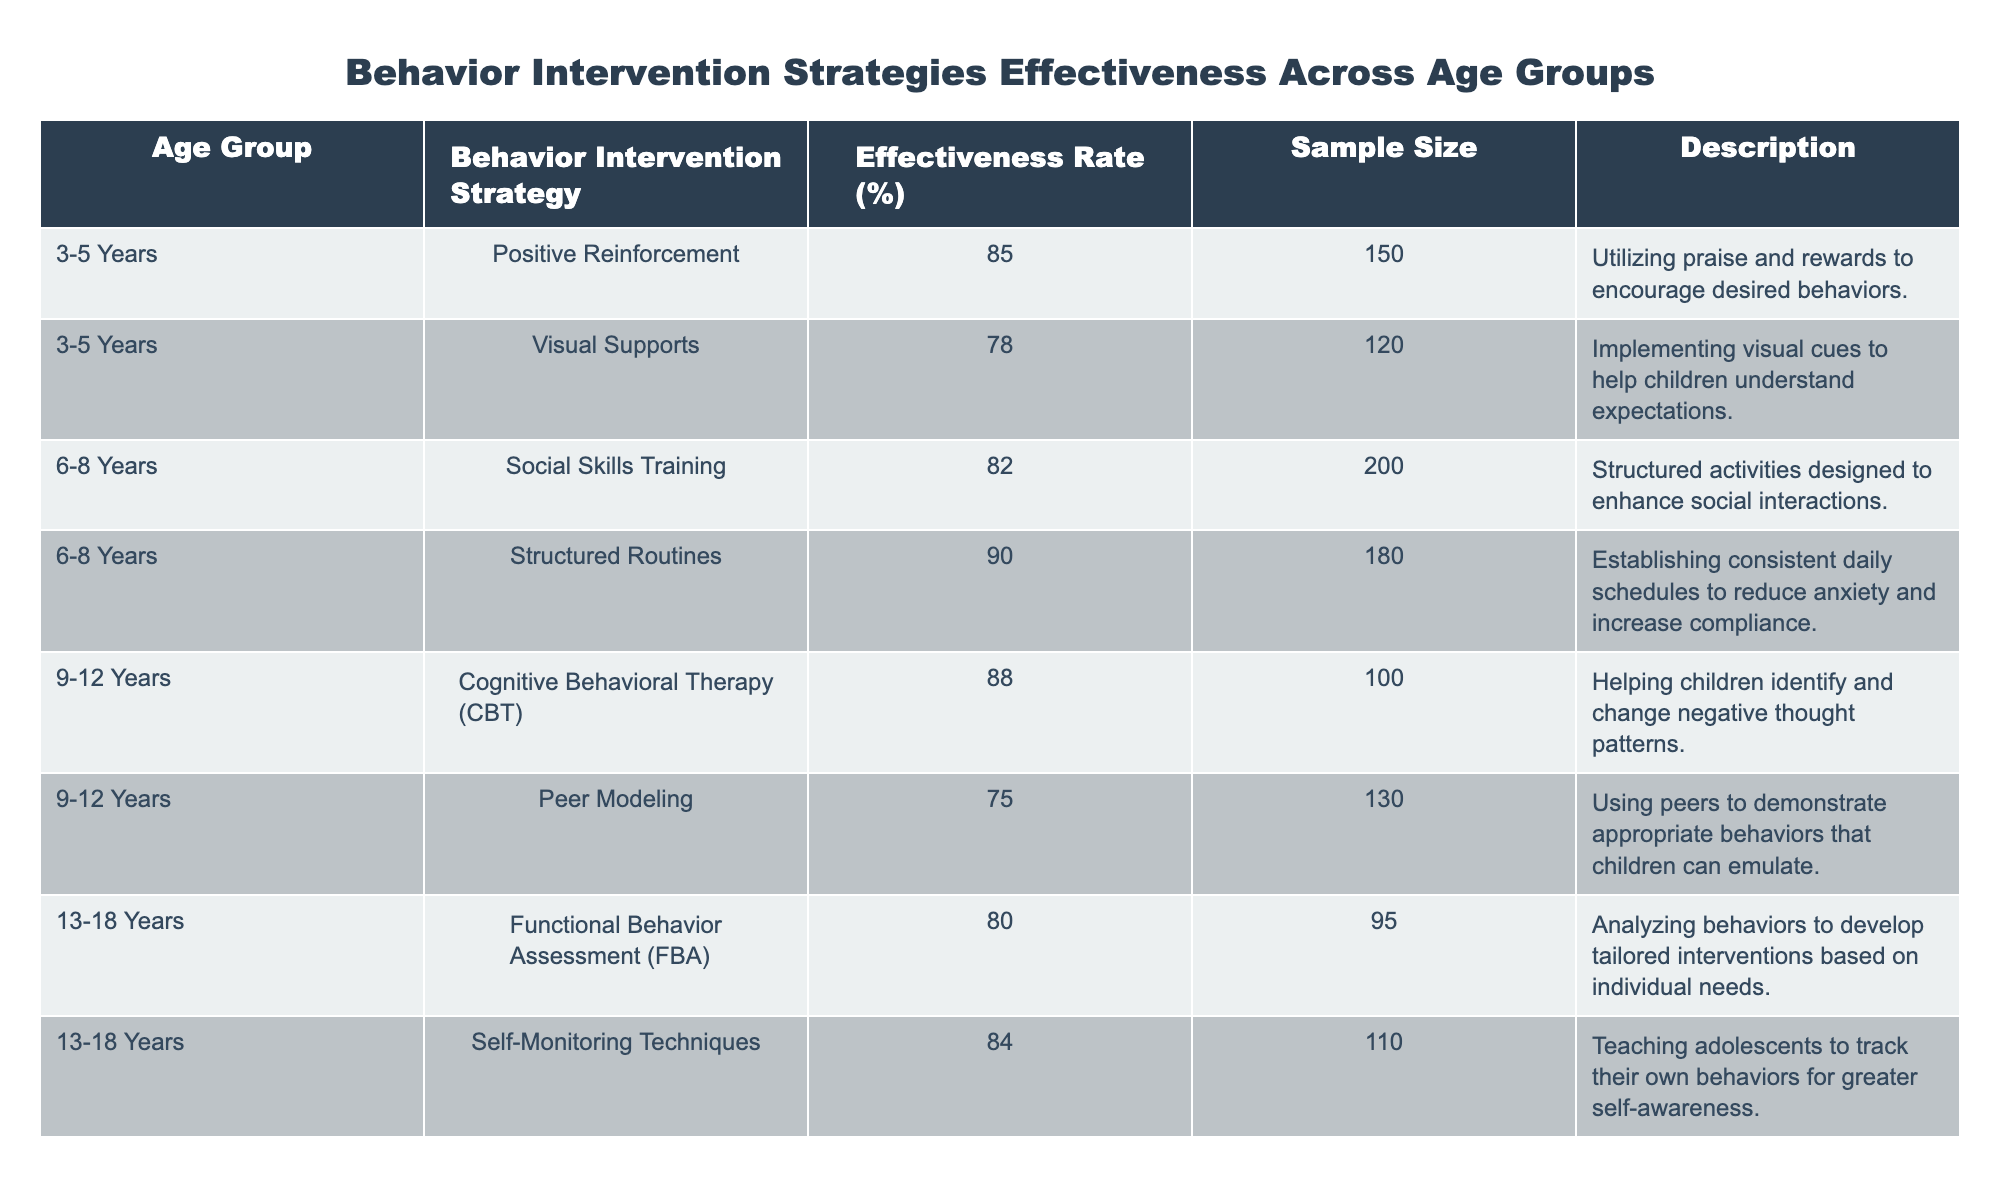What is the effectiveness rate of Positive Reinforcement for the age group 3-5 Years? The table shows that the effectiveness rate for Positive Reinforcement in the age group 3-5 Years is 85%.
Answer: 85% Which behavior intervention strategy has the highest effectiveness rate? According to the table, Structured Routines has the highest effectiveness rate of 90%.
Answer: 90% Is the effectiveness rate of Visual Supports greater than the effectiveness rate of Peer Modeling? The effectiveness rate for Visual Supports is 78%, while Peer Modeling has an effectiveness rate of 75%. Since 78% is greater than 75%, the statement is true.
Answer: Yes What is the average effectiveness rate for the age group 6-8 Years? The effectiveness rates for 6-8 Years are 82% (Social Skills Training) and 90% (Structured Routines). To find the average, add them: 82 + 90 = 172 and divide by 2 (the number of strategies), which equals 86%.
Answer: 86% How many total strategies are analyzed for the age group 9-12 Years? The table presents 2 strategies for the age group 9-12 Years: Cognitive Behavioral Therapy (CBT) and Peer Modeling. Therefore, the total is 2.
Answer: 2 What is the effectiveness rate difference between Social Skills Training and Functional Behavior Assessment (FBA)? The effectiveness rate for Social Skills Training is 82%, and for FBA, it is 80%. The difference is calculated by subtracting 80 from 82, resulting in a difference of 2%.
Answer: 2% Which age group has at least one intervention strategy with an effectiveness rate above 80%? The age groups 3-5 Years, 6-8 Years, 9-12 Years, and 13-18 Years all have at least one strategy above 80% (e.g., 85% for Positive Reinforcement, and 90% for Structured Routines, 88% for CBT, and 84% for Self-Monitoring Techniques). Thus, the statement is true.
Answer: Yes What is the total sample size for the age group 13-18 Years? The sample sizes for the age group 13-18 Years are 95 (FBA) and 110 (Self-Monitoring Techniques). Adding these gives 95 + 110 = 205.
Answer: 205 